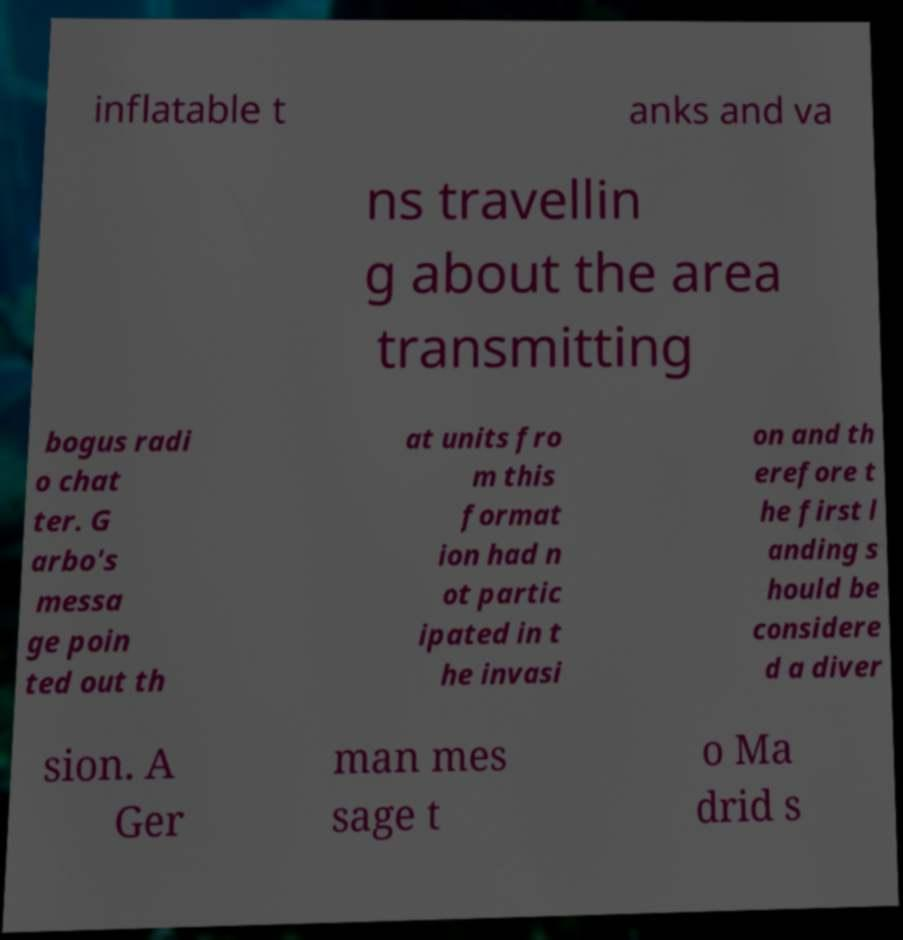I need the written content from this picture converted into text. Can you do that? inflatable t anks and va ns travellin g about the area transmitting bogus radi o chat ter. G arbo's messa ge poin ted out th at units fro m this format ion had n ot partic ipated in t he invasi on and th erefore t he first l anding s hould be considere d a diver sion. A Ger man mes sage t o Ma drid s 